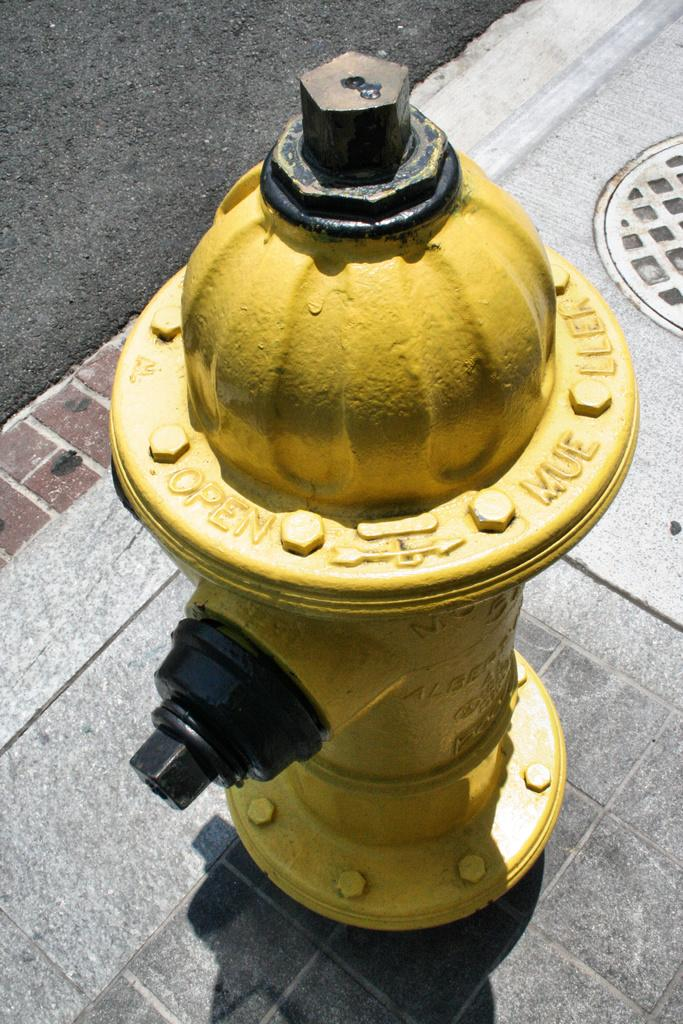What object is the main subject of the image? There is a fire hydrant in the image. What color is the fire hydrant? The fire hydrant is yellow. What type of surface is at the bottom of the image? There is a pavement at the bottom of the image. What can be seen to the left of the image? There is a road to the left of the image. What flavor of basin is depicted in the image? There is no basin present in the image, and therefore no flavor can be determined. Additionally, basins do not have flavors. 